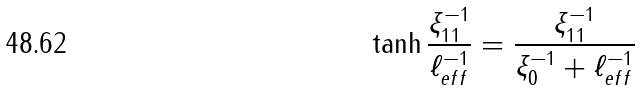Convert formula to latex. <formula><loc_0><loc_0><loc_500><loc_500>\tanh \frac { \xi _ { 1 1 } ^ { - 1 } } { \ell _ { e f f } ^ { - 1 } } = \frac { \xi _ { 1 1 } ^ { - 1 } } { \xi _ { 0 } ^ { - 1 } + \ell _ { e f f } ^ { - 1 } }</formula> 